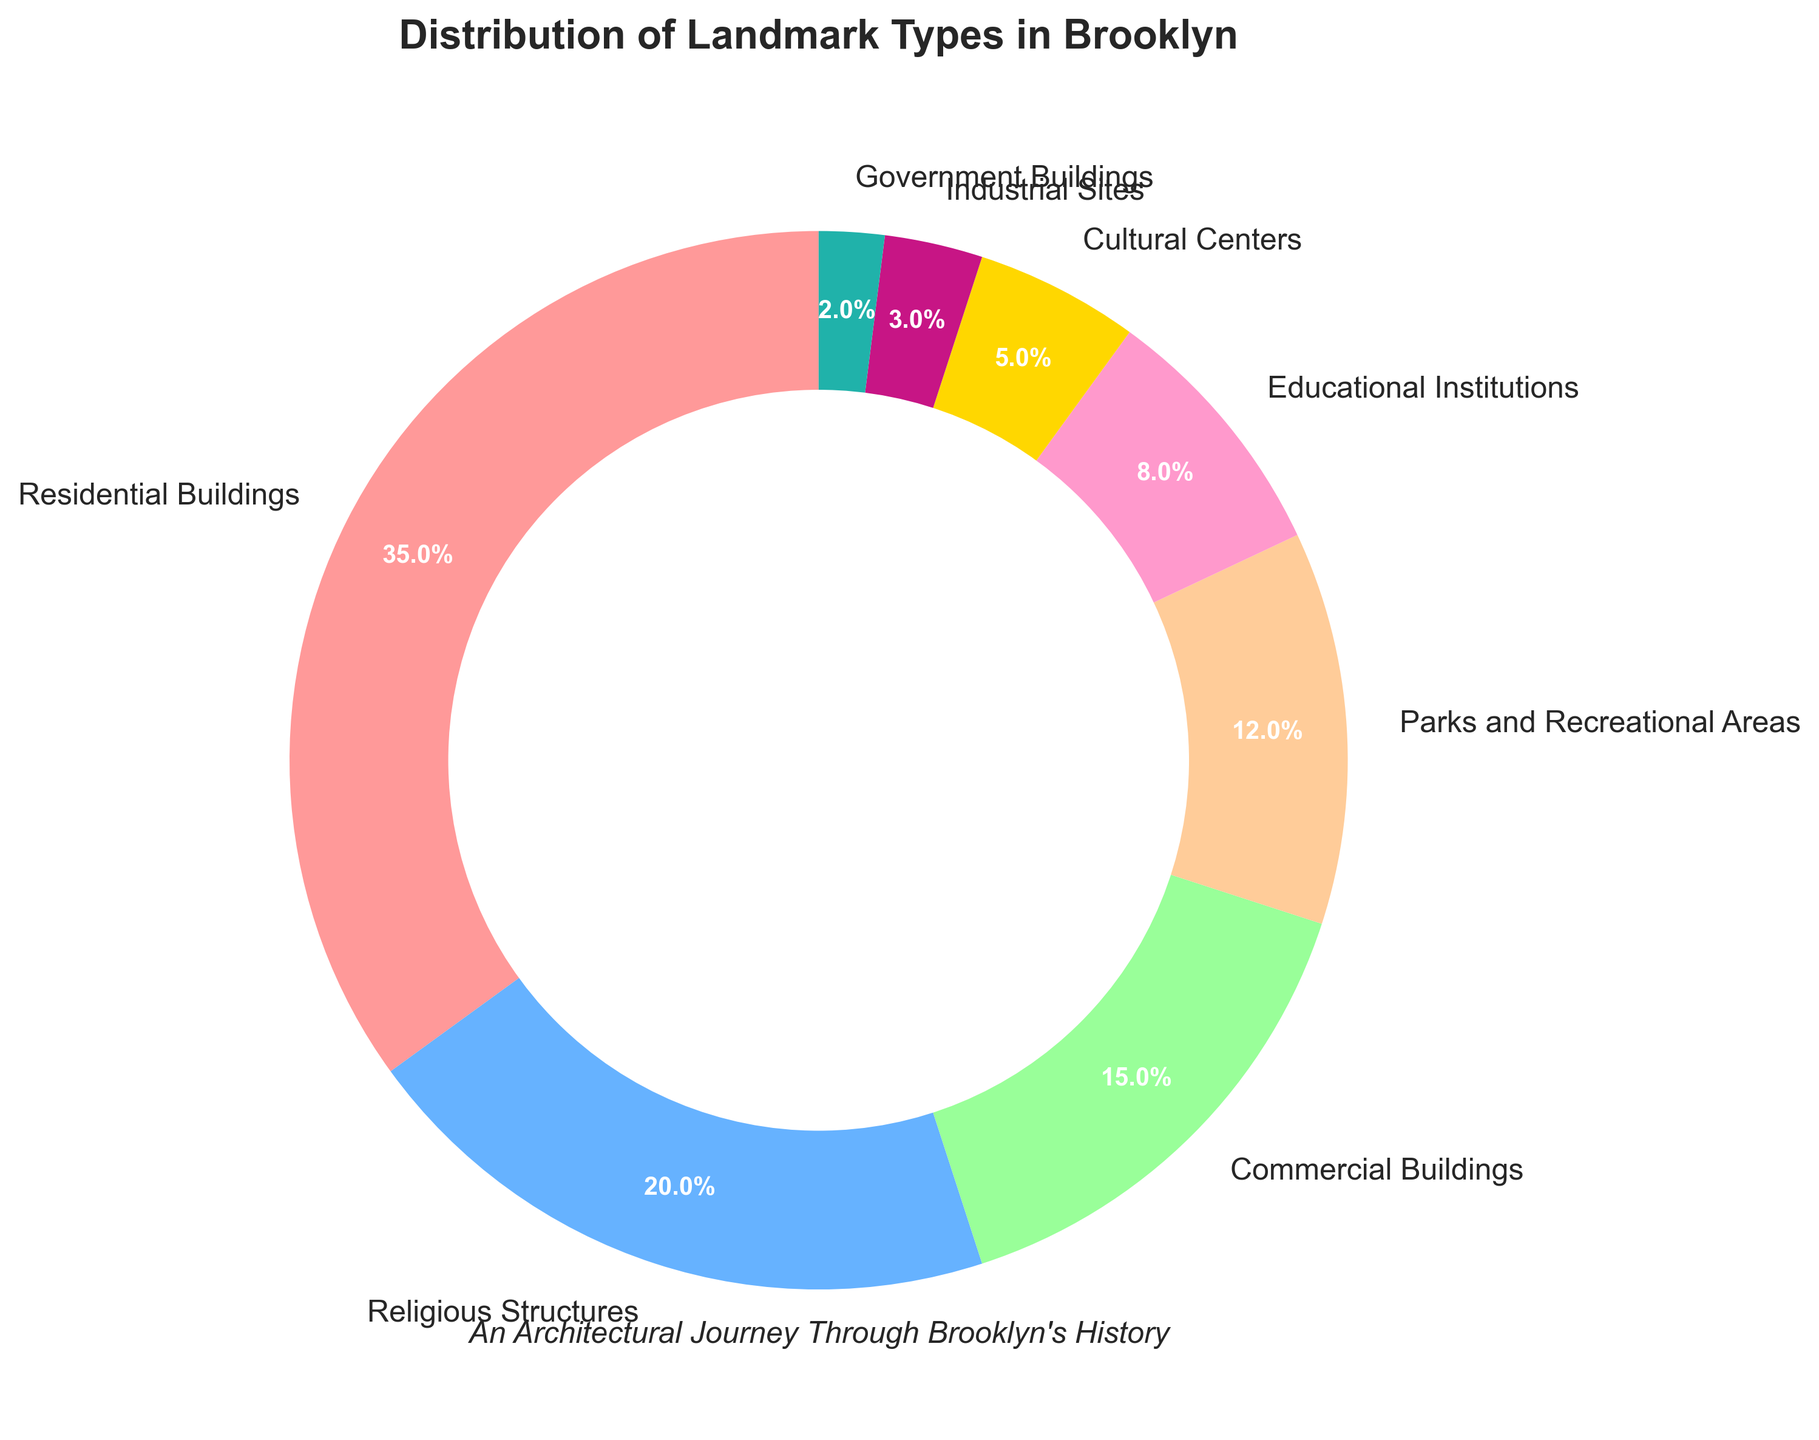What type of landmark encompasses the largest proportion in Brooklyn? The largest section in the pie chart is labeled "Residential Buildings".
Answer: Residential Buildings Which type of landmark has a smaller percentage, Parks and Recreational Areas or Educational Institutions? By comparing the sizes of the sections labeled "Parks and Recreational Areas" (12%) and "Educational Institutions" (8%), the latter is smaller.
Answer: Educational Institutions How much larger (in percentage points) is the Residential Buildings category compared to Commercial Buildings? The Residential Buildings category is 35%, and the Commercial Buildings category is 15%. The difference is calculated as 35% - 15% = 20%.
Answer: 20% Combine the proportion of Cultural Centers, Industrial Sites, and Government Buildings. What percentage of Brooklyn’s landmarks do they make up? Add the percentages of Cultural Centers (5%), Industrial Sites (3%), and Government Buildings (2%): 5% + 3% + 2% = 10%.
Answer: 10% Among the displayed categories, which one has the smallest representation? The smallest section in the pie chart is labeled "Government Buildings".
Answer: Government Buildings Are Parks and Recreational Areas more common than Commercial Buildings based on the chart? The chart shows Parks and Recreational Areas at 12% and Commercial Buildings at 15%, indicating that Commercial Buildings are more common.
Answer: No Exclude Residential Buildings and sum up the remaining percentages. What percentage of Brooklyn's landmarks is represented by these categories? Subtract the Residential Buildings percentage (35%) from 100%: 100% - 35% = 65%.
Answer: 65% Compare Religious Structures and Educational Institutions. How many percentage points more do Religious Structures contribute? Religious Structures are 20%, and Educational Institutions are 8%. The difference is 20% - 8% = 12%.
Answer: 12% What is the total percentage for all the categories that include Buildings in their name? Add the percentages for Residential (35%), Commercial (15%), and Government Buildings (2%): 35% + 15% + 2% = 52%.
Answer: 52% Which landmark type is represented by a green section in the pie chart? Based on most common color palettes used, Parks and Recreational Areas are often represented by green.
Answer: Parks and Recreational Areas 